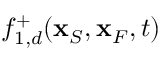<formula> <loc_0><loc_0><loc_500><loc_500>f _ { 1 , d } ^ { + } ( { x } _ { S } , { x } _ { F } , t )</formula> 